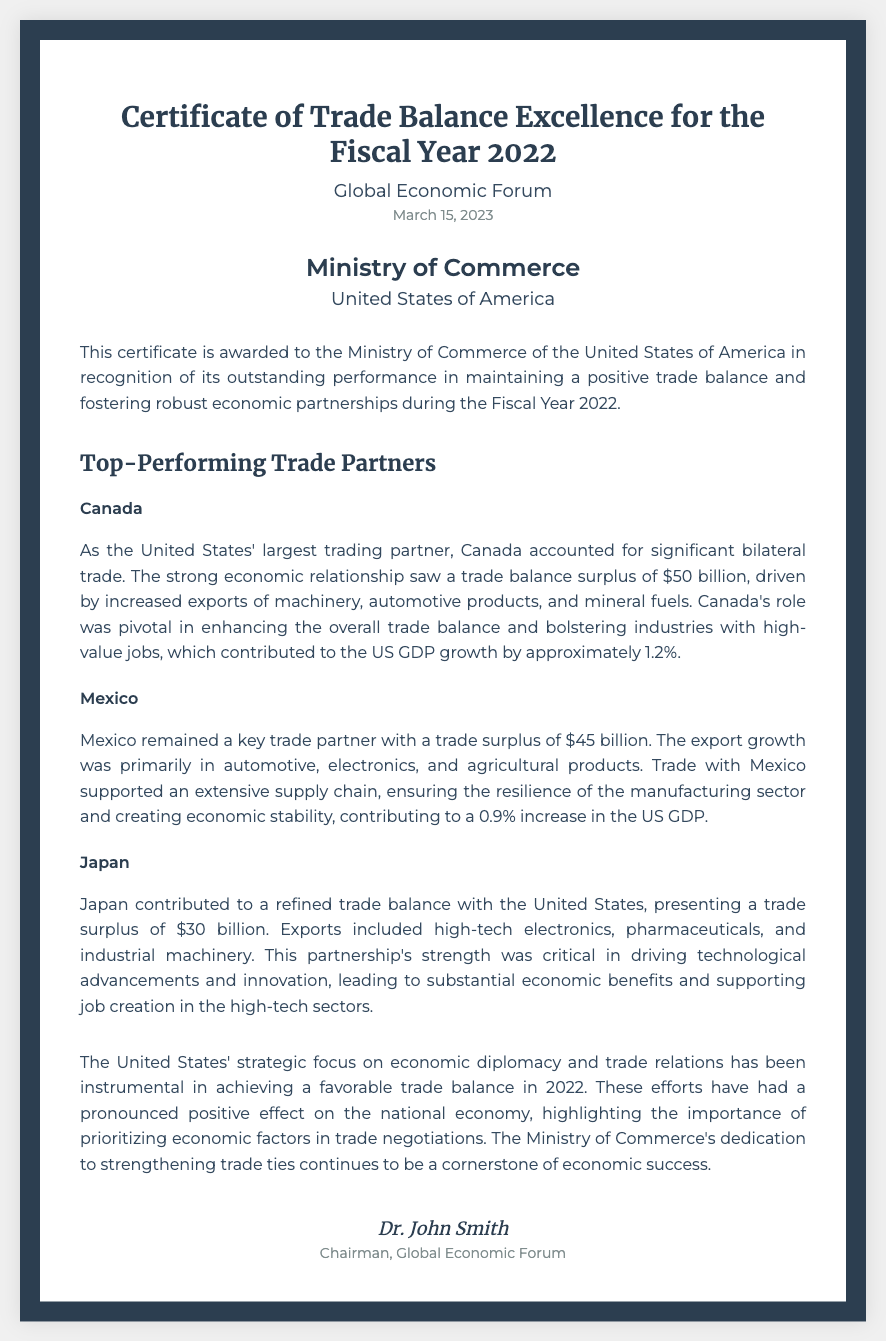What is the title of the document? The title of the document is prominently displayed at the top and indicates its purpose.
Answer: Certificate of Trade Balance Excellence for the Fiscal Year 2022 Who issued the certificate? The issuing organization is mentioned in the header of the document.
Answer: Global Economic Forum What was the trade surplus with Canada? The document specifies the trade surplus amount with Canada in the section about top-performing trade partners.
Answer: $50 billion What is the total trade surplus with Mexico? The document provides the trade surplus amount with Mexico in its description.
Answer: $45 billion What does the collaboration with Japan contribute to? This question refers to the summary provided in the description about Japan's economic impact.
Answer: Technological advancements What was the date of issue of this certificate? The date of issue is listed in the header section of the document.
Answer: March 15, 2023 What was the overall impact on the US GDP attributed to trade with Canada? The document includes an estimate of GDP growth linked to the partnership with Canada.
Answer: Approximately 1.2% Who is the signatory of the certificate? The document identifies the person who signed the certificate at the bottom.
Answer: Dr. John Smith What economic factor is emphasized in trade negotiations? The conclusion of the document discusses the importance of a particular element in negotiations.
Answer: Economic factors 